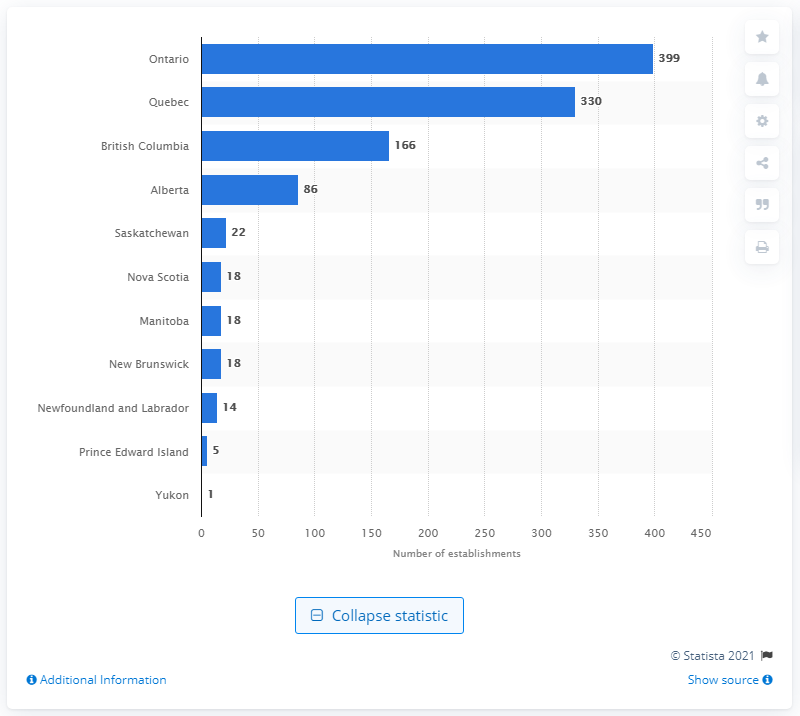Specify some key components in this picture. As of December 2020, there were 399 merchant wholesalers operating in the province of Ontario. 